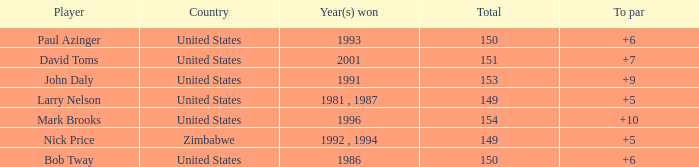How many to pars were won in 1993? 1.0. 